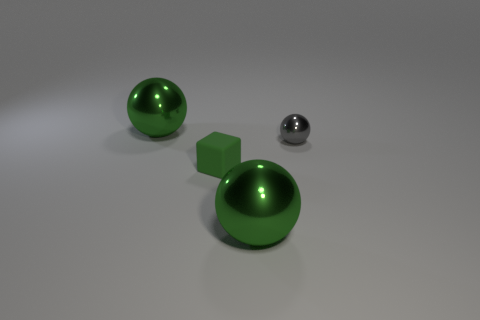Subtract all green balls. How many balls are left? 1 Add 4 red rubber cubes. How many objects exist? 8 Subtract all gray spheres. How many spheres are left? 2 Subtract 1 spheres. How many spheres are left? 2 Subtract all gray blocks. Subtract all green cylinders. How many blocks are left? 1 Subtract all blue blocks. How many red balls are left? 0 Subtract all small cyan spheres. Subtract all small green objects. How many objects are left? 3 Add 1 gray metal things. How many gray metal things are left? 2 Add 3 big objects. How many big objects exist? 5 Subtract 0 purple cylinders. How many objects are left? 4 